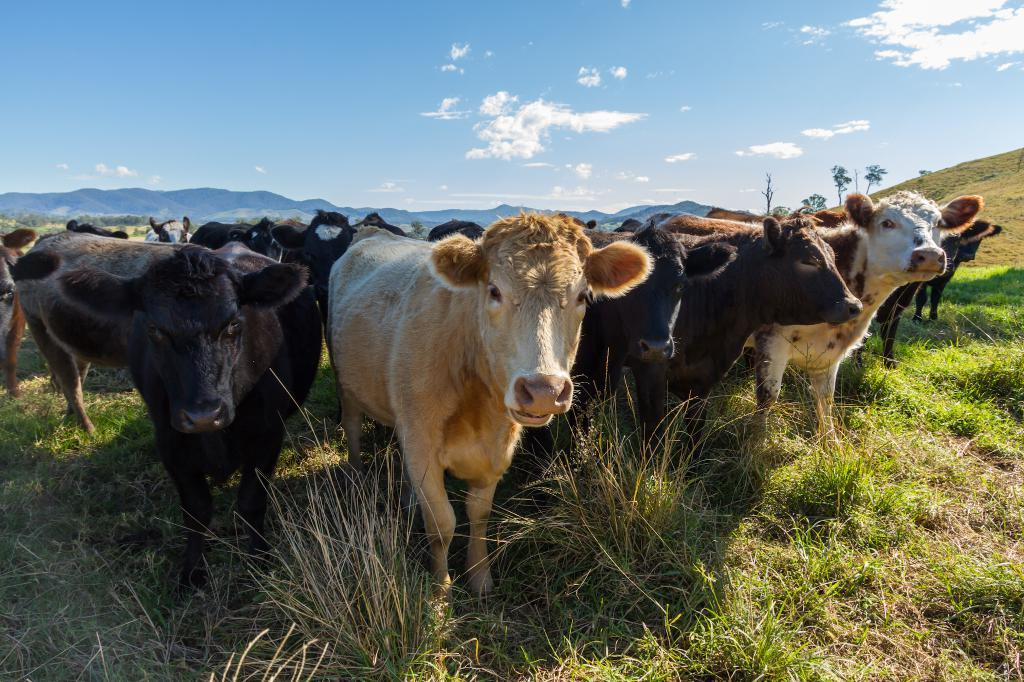What animals are in the image? There is a group of cows in the image. What is the cows' environment like? The cows are on grass, and there are trees and mountains in the image. What can be seen in the background of the image? The sky is visible in the background of the image, and clouds are present in the sky. What type of frame is around the cows in the image? There is no frame around the cows in the image; they are in an open environment. What club is the cow holding in the image? There are no clubs present in the image; the cows are simply grazing on grass. 